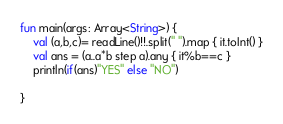Convert code to text. <code><loc_0><loc_0><loc_500><loc_500><_Kotlin_>fun main(args: Array<String>) {
    val (a,b,c)= readLine()!!.split(" ").map { it.toInt() }
    val ans = (a..a*b step a).any { it%b==c }
    println(if(ans)"YES" else "NO")

}</code> 